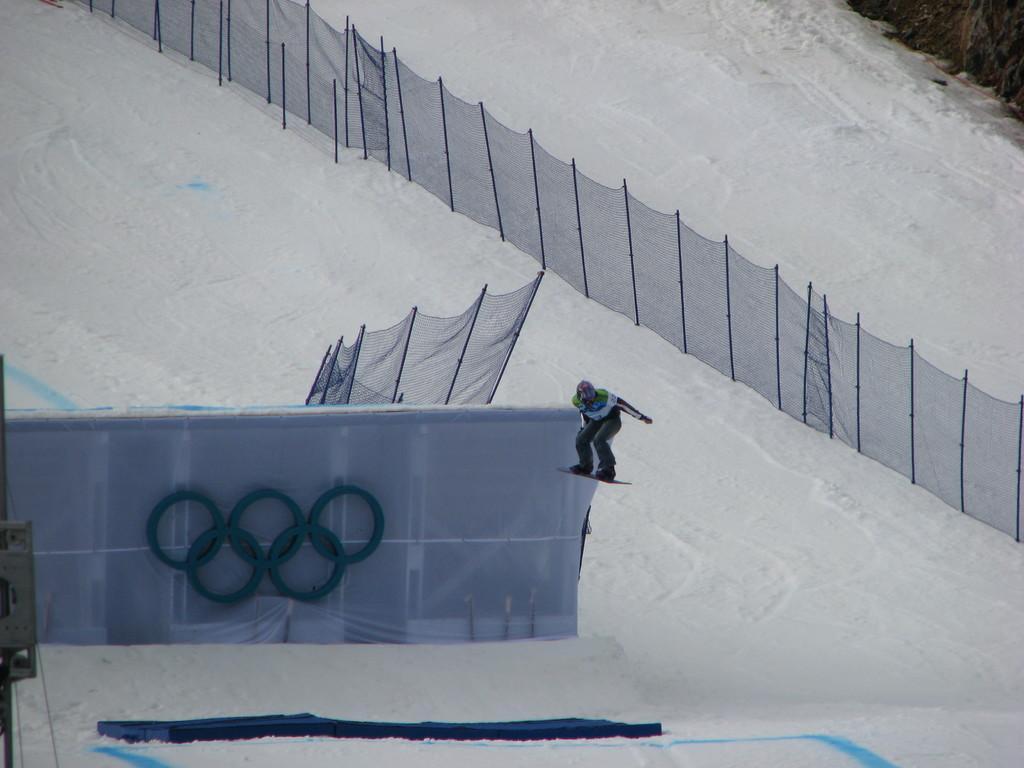How would you summarize this image in a sentence or two? In this image, we can see snow on the ground, there are some nets. We can see a person on the snowboard. 